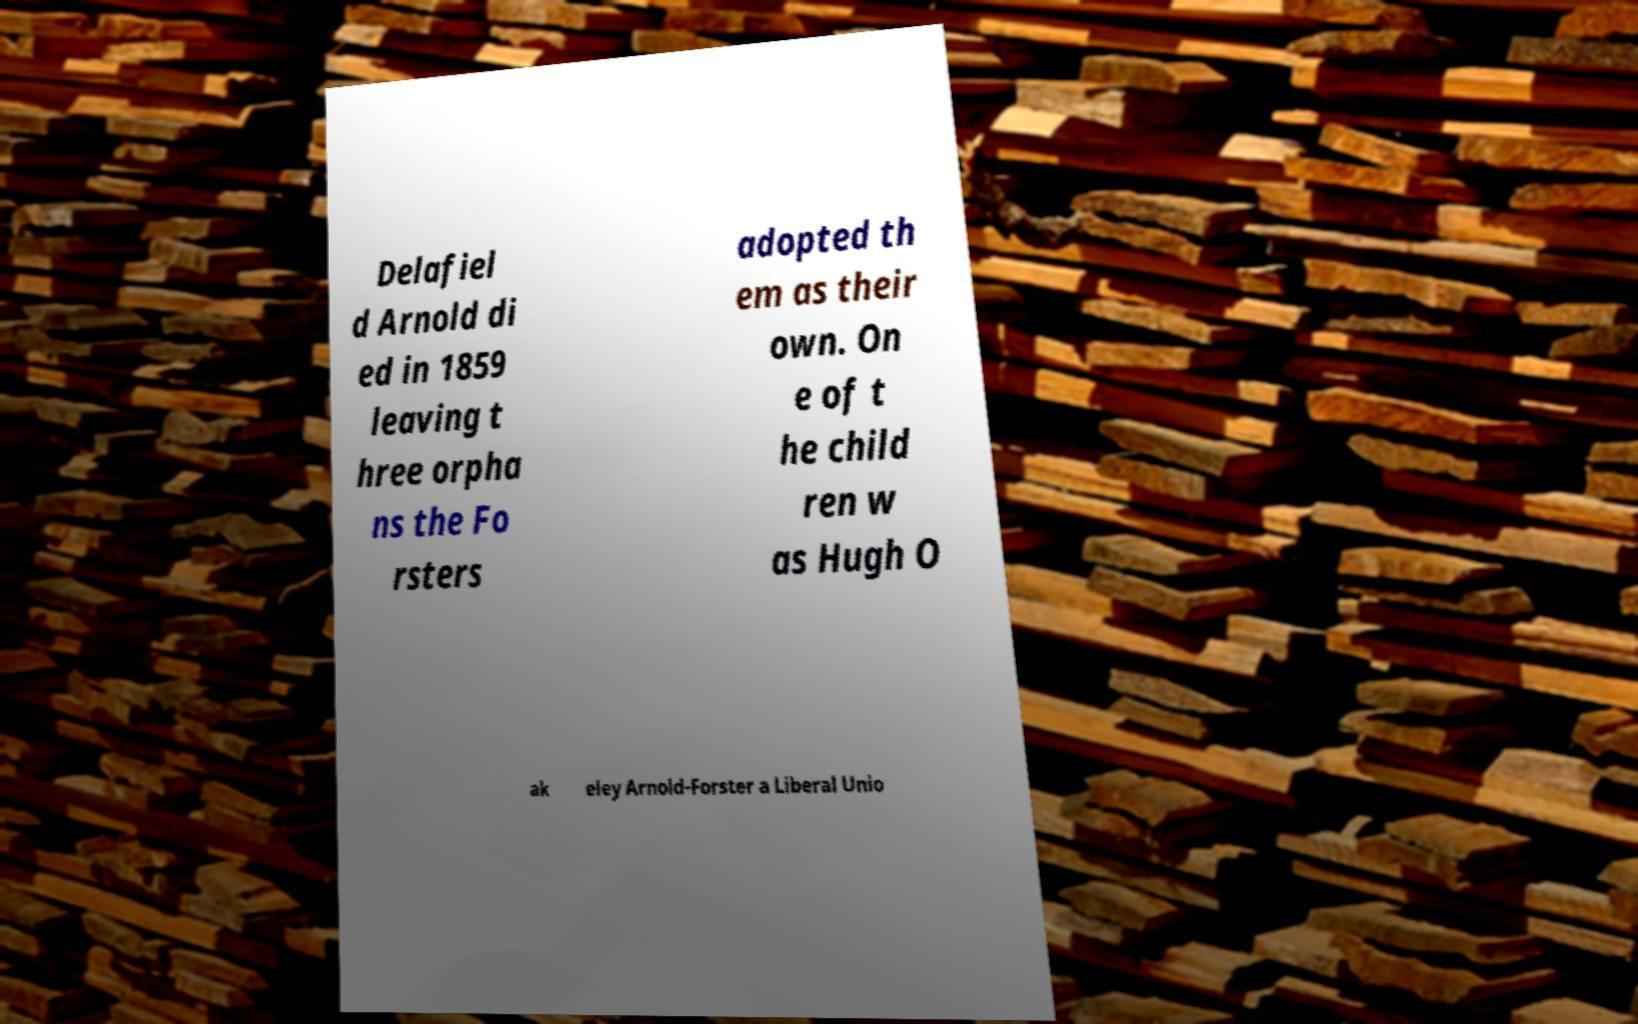Please read and relay the text visible in this image. What does it say? Delafiel d Arnold di ed in 1859 leaving t hree orpha ns the Fo rsters adopted th em as their own. On e of t he child ren w as Hugh O ak eley Arnold-Forster a Liberal Unio 